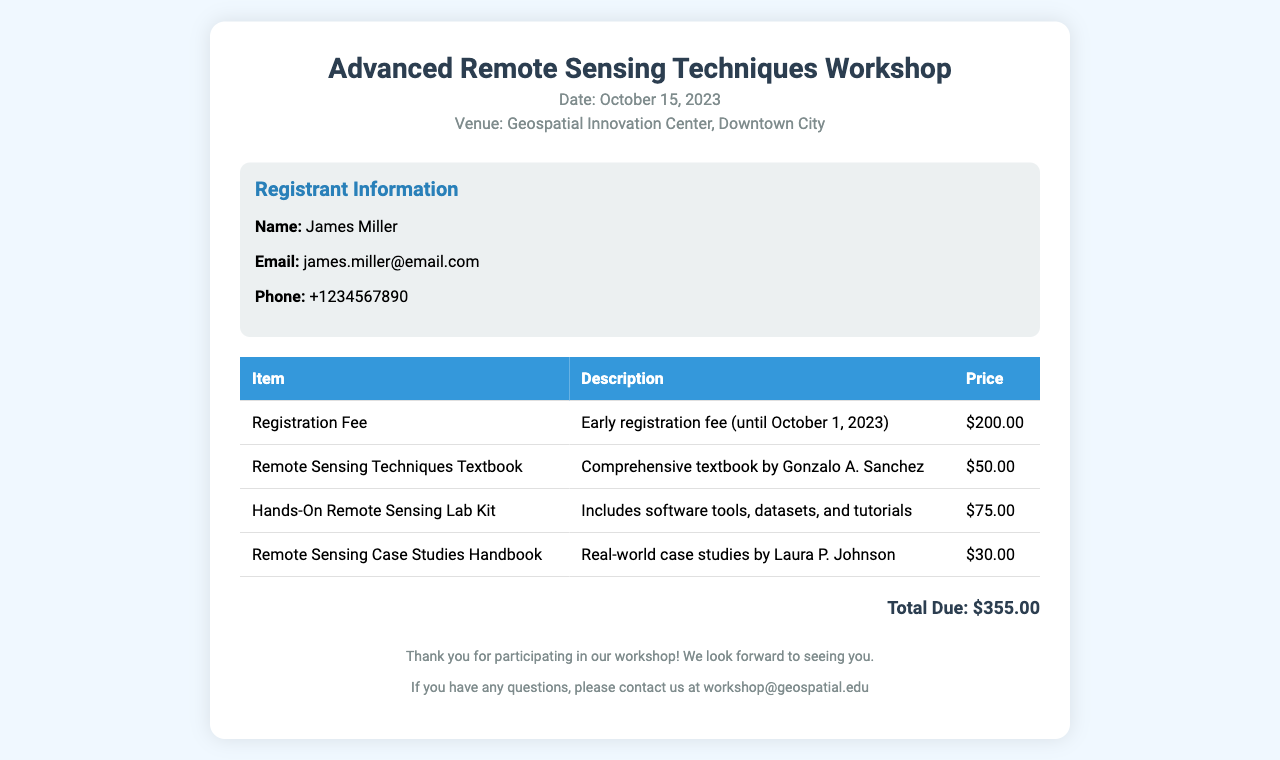What is the date of the workshop? The date of the workshop is specifically mentioned in the header of the document as October 15, 2023.
Answer: October 15, 2023 Who is the registrant? The registrant information section clearly lists the name of the registrant as James Miller.
Answer: James Miller What is the total due? The total due amount is highlighted at the end of the invoice, which sums up all the item prices as $355.00.
Answer: $355.00 What items were purchased? The document lists several items purchased, including a registration fee, textbook, lab kit, and handbook, which are outlined in the table.
Answer: Registration Fee, Remote Sensing Techniques Textbook, Hands-On Remote Sensing Lab Kit, Remote Sensing Case Studies Handbook What is the price of the Remote Sensing Techniques Textbook? The price of the Remote Sensing Techniques Textbook is specified in the table as $50.00.
Answer: $50.00 How many items are listed in the invoice? The table includes four different items, counting the registration fee as one of them.
Answer: Four What is the email address for inquiries? The footer of the document provides an email address for any questions related to the workshop, which is explicitly stated as workshop@geospatial.edu.
Answer: workshop@geospatial.edu What is the venue for the workshop? The venue is clearly mentioned in the header of the document as Geospatial Innovation Center, Downtown City.
Answer: Geospatial Innovation Center, Downtown City 